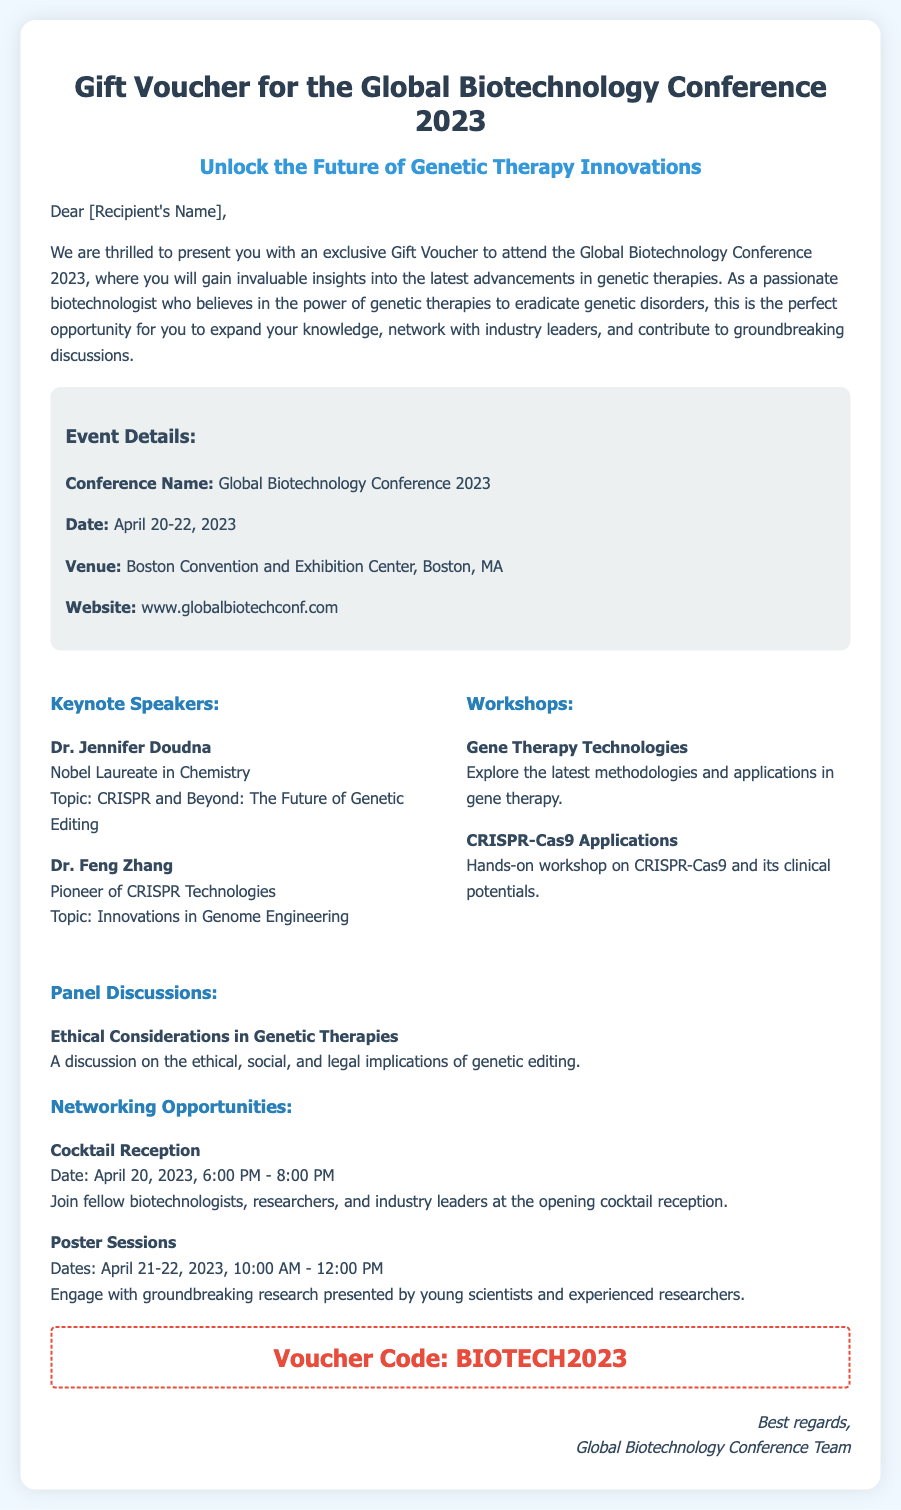What is the conference name? The conference name is explicitly mentioned in the document under event details.
Answer: Global Biotechnology Conference 2023 What is the venue for the conference? The venue is specified in the event details section of the document.
Answer: Boston Convention and Exhibition Center Who are the keynote speakers? The document lists the keynote speakers in the highlights section, requiring retrieval of specific names.
Answer: Dr. Jennifer Doudna, Dr. Feng Zhang What date does the conference start? The start date of the conference is mentioned in the event details section.
Answer: April 20, 2023 What type of workshop is offered at the conference? The document provides specific types of workshops in the highlights section.
Answer: Gene Therapy Technologies What is the voucher code? The voucher code is prominently displayed in the document.
Answer: BIOTECH2023 How long is the cocktail reception scheduled for? The duration of the cocktail reception is specified in the networking opportunities section.
Answer: 2 hours What is the topic of the panel discussion? The document specifies the topic of the panel discussion in the highlights section.
Answer: Ethical Considerations in Genetic Therapies How can attendees engage with research at the conference? The document describes interactive opportunities to engage with research, specifically noted in the highlights.
Answer: Poster Sessions 